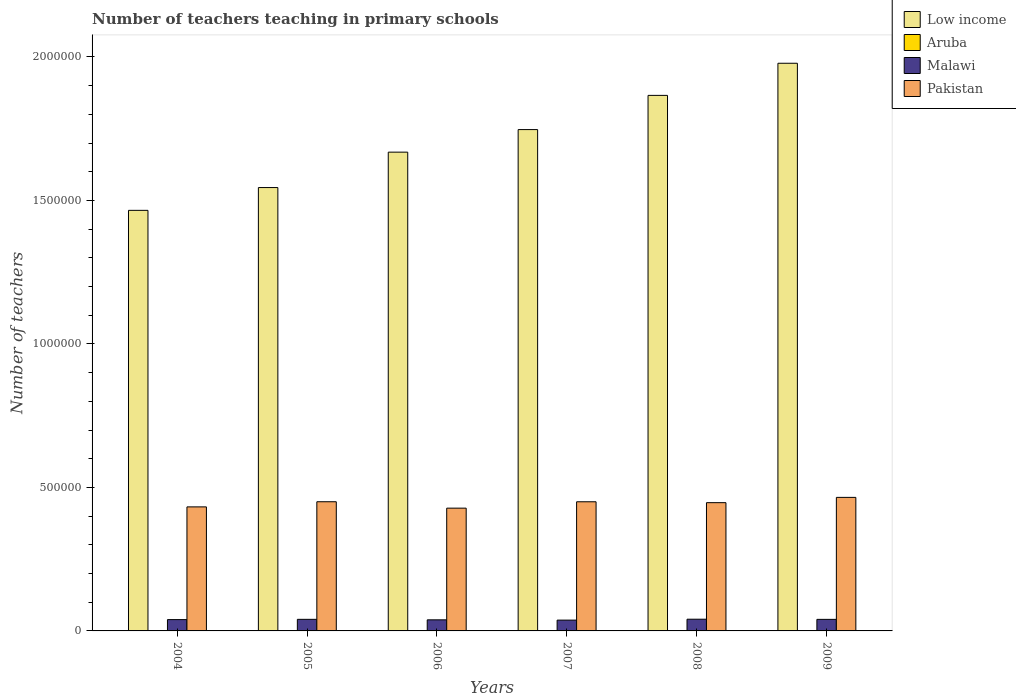How many groups of bars are there?
Give a very brief answer. 6. How many bars are there on the 6th tick from the right?
Your answer should be very brief. 4. What is the label of the 4th group of bars from the left?
Your answer should be very brief. 2007. What is the number of teachers teaching in primary schools in Malawi in 2006?
Provide a short and direct response. 3.86e+04. Across all years, what is the maximum number of teachers teaching in primary schools in Pakistan?
Your response must be concise. 4.65e+05. Across all years, what is the minimum number of teachers teaching in primary schools in Malawi?
Your answer should be very brief. 3.77e+04. In which year was the number of teachers teaching in primary schools in Malawi minimum?
Your answer should be compact. 2007. What is the total number of teachers teaching in primary schools in Pakistan in the graph?
Provide a succinct answer. 2.67e+06. What is the difference between the number of teachers teaching in primary schools in Pakistan in 2005 and that in 2007?
Give a very brief answer. 109. What is the difference between the number of teachers teaching in primary schools in Pakistan in 2006 and the number of teachers teaching in primary schools in Low income in 2004?
Offer a terse response. -1.04e+06. What is the average number of teachers teaching in primary schools in Low income per year?
Your answer should be compact. 1.71e+06. In the year 2007, what is the difference between the number of teachers teaching in primary schools in Aruba and number of teachers teaching in primary schools in Pakistan?
Offer a terse response. -4.49e+05. What is the ratio of the number of teachers teaching in primary schools in Pakistan in 2005 to that in 2006?
Your answer should be very brief. 1.05. What is the difference between the highest and the second highest number of teachers teaching in primary schools in Pakistan?
Your answer should be very brief. 1.52e+04. What is the difference between the highest and the lowest number of teachers teaching in primary schools in Aruba?
Your answer should be compact. 42. In how many years, is the number of teachers teaching in primary schools in Low income greater than the average number of teachers teaching in primary schools in Low income taken over all years?
Offer a terse response. 3. Is the sum of the number of teachers teaching in primary schools in Aruba in 2004 and 2008 greater than the maximum number of teachers teaching in primary schools in Pakistan across all years?
Make the answer very short. No. What does the 2nd bar from the left in 2009 represents?
Your response must be concise. Aruba. What does the 4th bar from the right in 2008 represents?
Keep it short and to the point. Low income. What is the difference between two consecutive major ticks on the Y-axis?
Your response must be concise. 5.00e+05. Are the values on the major ticks of Y-axis written in scientific E-notation?
Give a very brief answer. No. Does the graph contain any zero values?
Keep it short and to the point. No. What is the title of the graph?
Make the answer very short. Number of teachers teaching in primary schools. Does "Rwanda" appear as one of the legend labels in the graph?
Your answer should be very brief. No. What is the label or title of the X-axis?
Provide a short and direct response. Years. What is the label or title of the Y-axis?
Keep it short and to the point. Number of teachers. What is the Number of teachers of Low income in 2004?
Ensure brevity in your answer.  1.47e+06. What is the Number of teachers in Aruba in 2004?
Provide a succinct answer. 552. What is the Number of teachers of Malawi in 2004?
Provide a succinct answer. 3.94e+04. What is the Number of teachers in Pakistan in 2004?
Provide a succinct answer. 4.32e+05. What is the Number of teachers in Low income in 2005?
Your answer should be very brief. 1.55e+06. What is the Number of teachers of Aruba in 2005?
Make the answer very short. 567. What is the Number of teachers of Malawi in 2005?
Your response must be concise. 4.04e+04. What is the Number of teachers of Pakistan in 2005?
Offer a very short reply. 4.50e+05. What is the Number of teachers of Low income in 2006?
Your response must be concise. 1.67e+06. What is the Number of teachers of Aruba in 2006?
Make the answer very short. 572. What is the Number of teachers of Malawi in 2006?
Your response must be concise. 3.86e+04. What is the Number of teachers of Pakistan in 2006?
Provide a short and direct response. 4.28e+05. What is the Number of teachers of Low income in 2007?
Give a very brief answer. 1.75e+06. What is the Number of teachers in Aruba in 2007?
Your answer should be very brief. 594. What is the Number of teachers in Malawi in 2007?
Make the answer very short. 3.77e+04. What is the Number of teachers in Pakistan in 2007?
Keep it short and to the point. 4.50e+05. What is the Number of teachers in Low income in 2008?
Offer a very short reply. 1.87e+06. What is the Number of teachers in Aruba in 2008?
Keep it short and to the point. 579. What is the Number of teachers of Malawi in 2008?
Offer a terse response. 4.08e+04. What is the Number of teachers in Pakistan in 2008?
Your answer should be very brief. 4.47e+05. What is the Number of teachers in Low income in 2009?
Give a very brief answer. 1.98e+06. What is the Number of teachers in Aruba in 2009?
Your answer should be compact. 582. What is the Number of teachers in Malawi in 2009?
Offer a very short reply. 4.03e+04. What is the Number of teachers of Pakistan in 2009?
Offer a terse response. 4.65e+05. Across all years, what is the maximum Number of teachers in Low income?
Make the answer very short. 1.98e+06. Across all years, what is the maximum Number of teachers of Aruba?
Give a very brief answer. 594. Across all years, what is the maximum Number of teachers in Malawi?
Provide a succinct answer. 4.08e+04. Across all years, what is the maximum Number of teachers in Pakistan?
Provide a succinct answer. 4.65e+05. Across all years, what is the minimum Number of teachers in Low income?
Give a very brief answer. 1.47e+06. Across all years, what is the minimum Number of teachers of Aruba?
Your answer should be compact. 552. Across all years, what is the minimum Number of teachers of Malawi?
Make the answer very short. 3.77e+04. Across all years, what is the minimum Number of teachers of Pakistan?
Give a very brief answer. 4.28e+05. What is the total Number of teachers of Low income in the graph?
Your answer should be compact. 1.03e+07. What is the total Number of teachers of Aruba in the graph?
Make the answer very short. 3446. What is the total Number of teachers of Malawi in the graph?
Give a very brief answer. 2.37e+05. What is the total Number of teachers in Pakistan in the graph?
Offer a very short reply. 2.67e+06. What is the difference between the Number of teachers in Low income in 2004 and that in 2005?
Ensure brevity in your answer.  -7.94e+04. What is the difference between the Number of teachers in Malawi in 2004 and that in 2005?
Your response must be concise. -952. What is the difference between the Number of teachers of Pakistan in 2004 and that in 2005?
Give a very brief answer. -1.79e+04. What is the difference between the Number of teachers of Low income in 2004 and that in 2006?
Your answer should be very brief. -2.03e+05. What is the difference between the Number of teachers of Malawi in 2004 and that in 2006?
Give a very brief answer. 813. What is the difference between the Number of teachers of Pakistan in 2004 and that in 2006?
Ensure brevity in your answer.  4392. What is the difference between the Number of teachers in Low income in 2004 and that in 2007?
Your answer should be very brief. -2.81e+05. What is the difference between the Number of teachers of Aruba in 2004 and that in 2007?
Give a very brief answer. -42. What is the difference between the Number of teachers of Malawi in 2004 and that in 2007?
Make the answer very short. 1764. What is the difference between the Number of teachers of Pakistan in 2004 and that in 2007?
Offer a very short reply. -1.78e+04. What is the difference between the Number of teachers in Low income in 2004 and that in 2008?
Your answer should be compact. -4.01e+05. What is the difference between the Number of teachers in Malawi in 2004 and that in 2008?
Ensure brevity in your answer.  -1348. What is the difference between the Number of teachers in Pakistan in 2004 and that in 2008?
Ensure brevity in your answer.  -1.47e+04. What is the difference between the Number of teachers of Low income in 2004 and that in 2009?
Give a very brief answer. -5.13e+05. What is the difference between the Number of teachers in Malawi in 2004 and that in 2009?
Keep it short and to the point. -845. What is the difference between the Number of teachers in Pakistan in 2004 and that in 2009?
Make the answer very short. -3.31e+04. What is the difference between the Number of teachers in Low income in 2005 and that in 2006?
Make the answer very short. -1.23e+05. What is the difference between the Number of teachers in Aruba in 2005 and that in 2006?
Provide a short and direct response. -5. What is the difference between the Number of teachers in Malawi in 2005 and that in 2006?
Make the answer very short. 1765. What is the difference between the Number of teachers in Pakistan in 2005 and that in 2006?
Give a very brief answer. 2.23e+04. What is the difference between the Number of teachers of Low income in 2005 and that in 2007?
Give a very brief answer. -2.02e+05. What is the difference between the Number of teachers of Aruba in 2005 and that in 2007?
Make the answer very short. -27. What is the difference between the Number of teachers of Malawi in 2005 and that in 2007?
Offer a very short reply. 2716. What is the difference between the Number of teachers of Pakistan in 2005 and that in 2007?
Your answer should be compact. 109. What is the difference between the Number of teachers of Low income in 2005 and that in 2008?
Make the answer very short. -3.21e+05. What is the difference between the Number of teachers in Aruba in 2005 and that in 2008?
Provide a short and direct response. -12. What is the difference between the Number of teachers in Malawi in 2005 and that in 2008?
Provide a succinct answer. -396. What is the difference between the Number of teachers in Pakistan in 2005 and that in 2008?
Give a very brief answer. 3211. What is the difference between the Number of teachers in Low income in 2005 and that in 2009?
Make the answer very short. -4.33e+05. What is the difference between the Number of teachers in Malawi in 2005 and that in 2009?
Ensure brevity in your answer.  107. What is the difference between the Number of teachers in Pakistan in 2005 and that in 2009?
Ensure brevity in your answer.  -1.52e+04. What is the difference between the Number of teachers of Low income in 2006 and that in 2007?
Make the answer very short. -7.86e+04. What is the difference between the Number of teachers of Malawi in 2006 and that in 2007?
Your answer should be very brief. 951. What is the difference between the Number of teachers in Pakistan in 2006 and that in 2007?
Give a very brief answer. -2.22e+04. What is the difference between the Number of teachers in Low income in 2006 and that in 2008?
Provide a succinct answer. -1.98e+05. What is the difference between the Number of teachers in Malawi in 2006 and that in 2008?
Your response must be concise. -2161. What is the difference between the Number of teachers in Pakistan in 2006 and that in 2008?
Offer a terse response. -1.91e+04. What is the difference between the Number of teachers in Low income in 2006 and that in 2009?
Ensure brevity in your answer.  -3.10e+05. What is the difference between the Number of teachers in Aruba in 2006 and that in 2009?
Your answer should be very brief. -10. What is the difference between the Number of teachers of Malawi in 2006 and that in 2009?
Provide a short and direct response. -1658. What is the difference between the Number of teachers in Pakistan in 2006 and that in 2009?
Keep it short and to the point. -3.75e+04. What is the difference between the Number of teachers in Low income in 2007 and that in 2008?
Provide a short and direct response. -1.19e+05. What is the difference between the Number of teachers in Malawi in 2007 and that in 2008?
Your answer should be very brief. -3112. What is the difference between the Number of teachers in Pakistan in 2007 and that in 2008?
Your answer should be compact. 3102. What is the difference between the Number of teachers of Low income in 2007 and that in 2009?
Give a very brief answer. -2.31e+05. What is the difference between the Number of teachers of Aruba in 2007 and that in 2009?
Your response must be concise. 12. What is the difference between the Number of teachers of Malawi in 2007 and that in 2009?
Provide a succinct answer. -2609. What is the difference between the Number of teachers in Pakistan in 2007 and that in 2009?
Offer a terse response. -1.53e+04. What is the difference between the Number of teachers of Low income in 2008 and that in 2009?
Your response must be concise. -1.12e+05. What is the difference between the Number of teachers in Malawi in 2008 and that in 2009?
Your answer should be compact. 503. What is the difference between the Number of teachers in Pakistan in 2008 and that in 2009?
Your answer should be compact. -1.84e+04. What is the difference between the Number of teachers of Low income in 2004 and the Number of teachers of Aruba in 2005?
Your answer should be very brief. 1.46e+06. What is the difference between the Number of teachers in Low income in 2004 and the Number of teachers in Malawi in 2005?
Keep it short and to the point. 1.43e+06. What is the difference between the Number of teachers in Low income in 2004 and the Number of teachers in Pakistan in 2005?
Provide a short and direct response. 1.02e+06. What is the difference between the Number of teachers of Aruba in 2004 and the Number of teachers of Malawi in 2005?
Make the answer very short. -3.98e+04. What is the difference between the Number of teachers of Aruba in 2004 and the Number of teachers of Pakistan in 2005?
Make the answer very short. -4.50e+05. What is the difference between the Number of teachers in Malawi in 2004 and the Number of teachers in Pakistan in 2005?
Your answer should be very brief. -4.11e+05. What is the difference between the Number of teachers of Low income in 2004 and the Number of teachers of Aruba in 2006?
Provide a succinct answer. 1.46e+06. What is the difference between the Number of teachers of Low income in 2004 and the Number of teachers of Malawi in 2006?
Make the answer very short. 1.43e+06. What is the difference between the Number of teachers in Low income in 2004 and the Number of teachers in Pakistan in 2006?
Make the answer very short. 1.04e+06. What is the difference between the Number of teachers in Aruba in 2004 and the Number of teachers in Malawi in 2006?
Your answer should be compact. -3.81e+04. What is the difference between the Number of teachers in Aruba in 2004 and the Number of teachers in Pakistan in 2006?
Provide a succinct answer. -4.27e+05. What is the difference between the Number of teachers of Malawi in 2004 and the Number of teachers of Pakistan in 2006?
Your response must be concise. -3.88e+05. What is the difference between the Number of teachers in Low income in 2004 and the Number of teachers in Aruba in 2007?
Give a very brief answer. 1.46e+06. What is the difference between the Number of teachers of Low income in 2004 and the Number of teachers of Malawi in 2007?
Give a very brief answer. 1.43e+06. What is the difference between the Number of teachers in Low income in 2004 and the Number of teachers in Pakistan in 2007?
Ensure brevity in your answer.  1.02e+06. What is the difference between the Number of teachers of Aruba in 2004 and the Number of teachers of Malawi in 2007?
Make the answer very short. -3.71e+04. What is the difference between the Number of teachers of Aruba in 2004 and the Number of teachers of Pakistan in 2007?
Your answer should be very brief. -4.49e+05. What is the difference between the Number of teachers of Malawi in 2004 and the Number of teachers of Pakistan in 2007?
Provide a succinct answer. -4.11e+05. What is the difference between the Number of teachers of Low income in 2004 and the Number of teachers of Aruba in 2008?
Give a very brief answer. 1.46e+06. What is the difference between the Number of teachers of Low income in 2004 and the Number of teachers of Malawi in 2008?
Provide a succinct answer. 1.42e+06. What is the difference between the Number of teachers of Low income in 2004 and the Number of teachers of Pakistan in 2008?
Ensure brevity in your answer.  1.02e+06. What is the difference between the Number of teachers in Aruba in 2004 and the Number of teachers in Malawi in 2008?
Provide a succinct answer. -4.02e+04. What is the difference between the Number of teachers in Aruba in 2004 and the Number of teachers in Pakistan in 2008?
Make the answer very short. -4.46e+05. What is the difference between the Number of teachers of Malawi in 2004 and the Number of teachers of Pakistan in 2008?
Keep it short and to the point. -4.07e+05. What is the difference between the Number of teachers of Low income in 2004 and the Number of teachers of Aruba in 2009?
Offer a very short reply. 1.46e+06. What is the difference between the Number of teachers of Low income in 2004 and the Number of teachers of Malawi in 2009?
Keep it short and to the point. 1.43e+06. What is the difference between the Number of teachers in Low income in 2004 and the Number of teachers in Pakistan in 2009?
Provide a short and direct response. 1.00e+06. What is the difference between the Number of teachers in Aruba in 2004 and the Number of teachers in Malawi in 2009?
Your response must be concise. -3.97e+04. What is the difference between the Number of teachers of Aruba in 2004 and the Number of teachers of Pakistan in 2009?
Provide a short and direct response. -4.65e+05. What is the difference between the Number of teachers of Malawi in 2004 and the Number of teachers of Pakistan in 2009?
Your answer should be very brief. -4.26e+05. What is the difference between the Number of teachers in Low income in 2005 and the Number of teachers in Aruba in 2006?
Provide a short and direct response. 1.54e+06. What is the difference between the Number of teachers in Low income in 2005 and the Number of teachers in Malawi in 2006?
Make the answer very short. 1.51e+06. What is the difference between the Number of teachers in Low income in 2005 and the Number of teachers in Pakistan in 2006?
Ensure brevity in your answer.  1.12e+06. What is the difference between the Number of teachers in Aruba in 2005 and the Number of teachers in Malawi in 2006?
Give a very brief answer. -3.81e+04. What is the difference between the Number of teachers of Aruba in 2005 and the Number of teachers of Pakistan in 2006?
Keep it short and to the point. -4.27e+05. What is the difference between the Number of teachers in Malawi in 2005 and the Number of teachers in Pakistan in 2006?
Your response must be concise. -3.87e+05. What is the difference between the Number of teachers in Low income in 2005 and the Number of teachers in Aruba in 2007?
Give a very brief answer. 1.54e+06. What is the difference between the Number of teachers of Low income in 2005 and the Number of teachers of Malawi in 2007?
Make the answer very short. 1.51e+06. What is the difference between the Number of teachers in Low income in 2005 and the Number of teachers in Pakistan in 2007?
Your response must be concise. 1.09e+06. What is the difference between the Number of teachers of Aruba in 2005 and the Number of teachers of Malawi in 2007?
Your answer should be compact. -3.71e+04. What is the difference between the Number of teachers of Aruba in 2005 and the Number of teachers of Pakistan in 2007?
Keep it short and to the point. -4.49e+05. What is the difference between the Number of teachers of Malawi in 2005 and the Number of teachers of Pakistan in 2007?
Give a very brief answer. -4.10e+05. What is the difference between the Number of teachers of Low income in 2005 and the Number of teachers of Aruba in 2008?
Your answer should be compact. 1.54e+06. What is the difference between the Number of teachers of Low income in 2005 and the Number of teachers of Malawi in 2008?
Keep it short and to the point. 1.50e+06. What is the difference between the Number of teachers of Low income in 2005 and the Number of teachers of Pakistan in 2008?
Ensure brevity in your answer.  1.10e+06. What is the difference between the Number of teachers in Aruba in 2005 and the Number of teachers in Malawi in 2008?
Ensure brevity in your answer.  -4.02e+04. What is the difference between the Number of teachers in Aruba in 2005 and the Number of teachers in Pakistan in 2008?
Keep it short and to the point. -4.46e+05. What is the difference between the Number of teachers of Malawi in 2005 and the Number of teachers of Pakistan in 2008?
Your answer should be very brief. -4.07e+05. What is the difference between the Number of teachers of Low income in 2005 and the Number of teachers of Aruba in 2009?
Your answer should be very brief. 1.54e+06. What is the difference between the Number of teachers of Low income in 2005 and the Number of teachers of Malawi in 2009?
Give a very brief answer. 1.50e+06. What is the difference between the Number of teachers in Low income in 2005 and the Number of teachers in Pakistan in 2009?
Make the answer very short. 1.08e+06. What is the difference between the Number of teachers in Aruba in 2005 and the Number of teachers in Malawi in 2009?
Offer a very short reply. -3.97e+04. What is the difference between the Number of teachers in Aruba in 2005 and the Number of teachers in Pakistan in 2009?
Ensure brevity in your answer.  -4.65e+05. What is the difference between the Number of teachers of Malawi in 2005 and the Number of teachers of Pakistan in 2009?
Your answer should be very brief. -4.25e+05. What is the difference between the Number of teachers of Low income in 2006 and the Number of teachers of Aruba in 2007?
Provide a succinct answer. 1.67e+06. What is the difference between the Number of teachers of Low income in 2006 and the Number of teachers of Malawi in 2007?
Offer a very short reply. 1.63e+06. What is the difference between the Number of teachers of Low income in 2006 and the Number of teachers of Pakistan in 2007?
Make the answer very short. 1.22e+06. What is the difference between the Number of teachers in Aruba in 2006 and the Number of teachers in Malawi in 2007?
Offer a very short reply. -3.71e+04. What is the difference between the Number of teachers in Aruba in 2006 and the Number of teachers in Pakistan in 2007?
Provide a succinct answer. -4.49e+05. What is the difference between the Number of teachers in Malawi in 2006 and the Number of teachers in Pakistan in 2007?
Provide a short and direct response. -4.11e+05. What is the difference between the Number of teachers in Low income in 2006 and the Number of teachers in Aruba in 2008?
Keep it short and to the point. 1.67e+06. What is the difference between the Number of teachers in Low income in 2006 and the Number of teachers in Malawi in 2008?
Provide a succinct answer. 1.63e+06. What is the difference between the Number of teachers in Low income in 2006 and the Number of teachers in Pakistan in 2008?
Your answer should be compact. 1.22e+06. What is the difference between the Number of teachers of Aruba in 2006 and the Number of teachers of Malawi in 2008?
Your answer should be very brief. -4.02e+04. What is the difference between the Number of teachers of Aruba in 2006 and the Number of teachers of Pakistan in 2008?
Offer a very short reply. -4.46e+05. What is the difference between the Number of teachers in Malawi in 2006 and the Number of teachers in Pakistan in 2008?
Offer a very short reply. -4.08e+05. What is the difference between the Number of teachers in Low income in 2006 and the Number of teachers in Aruba in 2009?
Provide a short and direct response. 1.67e+06. What is the difference between the Number of teachers in Low income in 2006 and the Number of teachers in Malawi in 2009?
Keep it short and to the point. 1.63e+06. What is the difference between the Number of teachers in Low income in 2006 and the Number of teachers in Pakistan in 2009?
Provide a short and direct response. 1.20e+06. What is the difference between the Number of teachers in Aruba in 2006 and the Number of teachers in Malawi in 2009?
Keep it short and to the point. -3.97e+04. What is the difference between the Number of teachers of Aruba in 2006 and the Number of teachers of Pakistan in 2009?
Your answer should be very brief. -4.65e+05. What is the difference between the Number of teachers of Malawi in 2006 and the Number of teachers of Pakistan in 2009?
Keep it short and to the point. -4.27e+05. What is the difference between the Number of teachers of Low income in 2007 and the Number of teachers of Aruba in 2008?
Keep it short and to the point. 1.75e+06. What is the difference between the Number of teachers in Low income in 2007 and the Number of teachers in Malawi in 2008?
Make the answer very short. 1.71e+06. What is the difference between the Number of teachers of Low income in 2007 and the Number of teachers of Pakistan in 2008?
Give a very brief answer. 1.30e+06. What is the difference between the Number of teachers in Aruba in 2007 and the Number of teachers in Malawi in 2008?
Offer a very short reply. -4.02e+04. What is the difference between the Number of teachers of Aruba in 2007 and the Number of teachers of Pakistan in 2008?
Your response must be concise. -4.46e+05. What is the difference between the Number of teachers of Malawi in 2007 and the Number of teachers of Pakistan in 2008?
Your response must be concise. -4.09e+05. What is the difference between the Number of teachers in Low income in 2007 and the Number of teachers in Aruba in 2009?
Give a very brief answer. 1.75e+06. What is the difference between the Number of teachers of Low income in 2007 and the Number of teachers of Malawi in 2009?
Provide a succinct answer. 1.71e+06. What is the difference between the Number of teachers in Low income in 2007 and the Number of teachers in Pakistan in 2009?
Offer a very short reply. 1.28e+06. What is the difference between the Number of teachers of Aruba in 2007 and the Number of teachers of Malawi in 2009?
Offer a terse response. -3.97e+04. What is the difference between the Number of teachers of Aruba in 2007 and the Number of teachers of Pakistan in 2009?
Offer a terse response. -4.65e+05. What is the difference between the Number of teachers of Malawi in 2007 and the Number of teachers of Pakistan in 2009?
Provide a short and direct response. -4.28e+05. What is the difference between the Number of teachers of Low income in 2008 and the Number of teachers of Aruba in 2009?
Offer a very short reply. 1.87e+06. What is the difference between the Number of teachers in Low income in 2008 and the Number of teachers in Malawi in 2009?
Keep it short and to the point. 1.83e+06. What is the difference between the Number of teachers in Low income in 2008 and the Number of teachers in Pakistan in 2009?
Ensure brevity in your answer.  1.40e+06. What is the difference between the Number of teachers of Aruba in 2008 and the Number of teachers of Malawi in 2009?
Your answer should be compact. -3.97e+04. What is the difference between the Number of teachers of Aruba in 2008 and the Number of teachers of Pakistan in 2009?
Your answer should be compact. -4.65e+05. What is the difference between the Number of teachers of Malawi in 2008 and the Number of teachers of Pakistan in 2009?
Offer a very short reply. -4.25e+05. What is the average Number of teachers of Low income per year?
Offer a very short reply. 1.71e+06. What is the average Number of teachers in Aruba per year?
Provide a short and direct response. 574.33. What is the average Number of teachers of Malawi per year?
Your answer should be compact. 3.95e+04. What is the average Number of teachers of Pakistan per year?
Provide a short and direct response. 4.45e+05. In the year 2004, what is the difference between the Number of teachers in Low income and Number of teachers in Aruba?
Provide a short and direct response. 1.47e+06. In the year 2004, what is the difference between the Number of teachers in Low income and Number of teachers in Malawi?
Offer a terse response. 1.43e+06. In the year 2004, what is the difference between the Number of teachers of Low income and Number of teachers of Pakistan?
Your answer should be compact. 1.03e+06. In the year 2004, what is the difference between the Number of teachers of Aruba and Number of teachers of Malawi?
Make the answer very short. -3.89e+04. In the year 2004, what is the difference between the Number of teachers in Aruba and Number of teachers in Pakistan?
Your response must be concise. -4.32e+05. In the year 2004, what is the difference between the Number of teachers of Malawi and Number of teachers of Pakistan?
Your answer should be compact. -3.93e+05. In the year 2005, what is the difference between the Number of teachers of Low income and Number of teachers of Aruba?
Ensure brevity in your answer.  1.54e+06. In the year 2005, what is the difference between the Number of teachers of Low income and Number of teachers of Malawi?
Your answer should be very brief. 1.50e+06. In the year 2005, what is the difference between the Number of teachers of Low income and Number of teachers of Pakistan?
Your answer should be very brief. 1.09e+06. In the year 2005, what is the difference between the Number of teachers of Aruba and Number of teachers of Malawi?
Keep it short and to the point. -3.98e+04. In the year 2005, what is the difference between the Number of teachers in Aruba and Number of teachers in Pakistan?
Keep it short and to the point. -4.50e+05. In the year 2005, what is the difference between the Number of teachers in Malawi and Number of teachers in Pakistan?
Provide a short and direct response. -4.10e+05. In the year 2006, what is the difference between the Number of teachers in Low income and Number of teachers in Aruba?
Offer a terse response. 1.67e+06. In the year 2006, what is the difference between the Number of teachers in Low income and Number of teachers in Malawi?
Make the answer very short. 1.63e+06. In the year 2006, what is the difference between the Number of teachers in Low income and Number of teachers in Pakistan?
Your response must be concise. 1.24e+06. In the year 2006, what is the difference between the Number of teachers of Aruba and Number of teachers of Malawi?
Give a very brief answer. -3.81e+04. In the year 2006, what is the difference between the Number of teachers of Aruba and Number of teachers of Pakistan?
Your answer should be very brief. -4.27e+05. In the year 2006, what is the difference between the Number of teachers of Malawi and Number of teachers of Pakistan?
Make the answer very short. -3.89e+05. In the year 2007, what is the difference between the Number of teachers of Low income and Number of teachers of Aruba?
Keep it short and to the point. 1.75e+06. In the year 2007, what is the difference between the Number of teachers of Low income and Number of teachers of Malawi?
Ensure brevity in your answer.  1.71e+06. In the year 2007, what is the difference between the Number of teachers in Low income and Number of teachers in Pakistan?
Offer a very short reply. 1.30e+06. In the year 2007, what is the difference between the Number of teachers of Aruba and Number of teachers of Malawi?
Offer a very short reply. -3.71e+04. In the year 2007, what is the difference between the Number of teachers of Aruba and Number of teachers of Pakistan?
Your answer should be compact. -4.49e+05. In the year 2007, what is the difference between the Number of teachers of Malawi and Number of teachers of Pakistan?
Offer a very short reply. -4.12e+05. In the year 2008, what is the difference between the Number of teachers of Low income and Number of teachers of Aruba?
Offer a very short reply. 1.87e+06. In the year 2008, what is the difference between the Number of teachers of Low income and Number of teachers of Malawi?
Offer a terse response. 1.83e+06. In the year 2008, what is the difference between the Number of teachers in Low income and Number of teachers in Pakistan?
Ensure brevity in your answer.  1.42e+06. In the year 2008, what is the difference between the Number of teachers of Aruba and Number of teachers of Malawi?
Provide a short and direct response. -4.02e+04. In the year 2008, what is the difference between the Number of teachers in Aruba and Number of teachers in Pakistan?
Offer a terse response. -4.46e+05. In the year 2008, what is the difference between the Number of teachers of Malawi and Number of teachers of Pakistan?
Your response must be concise. -4.06e+05. In the year 2009, what is the difference between the Number of teachers of Low income and Number of teachers of Aruba?
Make the answer very short. 1.98e+06. In the year 2009, what is the difference between the Number of teachers of Low income and Number of teachers of Malawi?
Make the answer very short. 1.94e+06. In the year 2009, what is the difference between the Number of teachers in Low income and Number of teachers in Pakistan?
Give a very brief answer. 1.51e+06. In the year 2009, what is the difference between the Number of teachers in Aruba and Number of teachers in Malawi?
Give a very brief answer. -3.97e+04. In the year 2009, what is the difference between the Number of teachers in Aruba and Number of teachers in Pakistan?
Provide a short and direct response. -4.65e+05. In the year 2009, what is the difference between the Number of teachers in Malawi and Number of teachers in Pakistan?
Provide a short and direct response. -4.25e+05. What is the ratio of the Number of teachers in Low income in 2004 to that in 2005?
Provide a succinct answer. 0.95. What is the ratio of the Number of teachers in Aruba in 2004 to that in 2005?
Keep it short and to the point. 0.97. What is the ratio of the Number of teachers in Malawi in 2004 to that in 2005?
Offer a terse response. 0.98. What is the ratio of the Number of teachers in Pakistan in 2004 to that in 2005?
Provide a short and direct response. 0.96. What is the ratio of the Number of teachers in Low income in 2004 to that in 2006?
Provide a succinct answer. 0.88. What is the ratio of the Number of teachers in Aruba in 2004 to that in 2006?
Make the answer very short. 0.96. What is the ratio of the Number of teachers of Pakistan in 2004 to that in 2006?
Offer a very short reply. 1.01. What is the ratio of the Number of teachers of Low income in 2004 to that in 2007?
Your answer should be very brief. 0.84. What is the ratio of the Number of teachers in Aruba in 2004 to that in 2007?
Your answer should be compact. 0.93. What is the ratio of the Number of teachers of Malawi in 2004 to that in 2007?
Give a very brief answer. 1.05. What is the ratio of the Number of teachers in Pakistan in 2004 to that in 2007?
Ensure brevity in your answer.  0.96. What is the ratio of the Number of teachers of Low income in 2004 to that in 2008?
Provide a short and direct response. 0.79. What is the ratio of the Number of teachers in Aruba in 2004 to that in 2008?
Your answer should be compact. 0.95. What is the ratio of the Number of teachers in Malawi in 2004 to that in 2008?
Offer a terse response. 0.97. What is the ratio of the Number of teachers of Pakistan in 2004 to that in 2008?
Provide a short and direct response. 0.97. What is the ratio of the Number of teachers in Low income in 2004 to that in 2009?
Make the answer very short. 0.74. What is the ratio of the Number of teachers of Aruba in 2004 to that in 2009?
Make the answer very short. 0.95. What is the ratio of the Number of teachers in Malawi in 2004 to that in 2009?
Offer a very short reply. 0.98. What is the ratio of the Number of teachers of Pakistan in 2004 to that in 2009?
Make the answer very short. 0.93. What is the ratio of the Number of teachers of Low income in 2005 to that in 2006?
Your answer should be compact. 0.93. What is the ratio of the Number of teachers of Aruba in 2005 to that in 2006?
Offer a very short reply. 0.99. What is the ratio of the Number of teachers in Malawi in 2005 to that in 2006?
Offer a terse response. 1.05. What is the ratio of the Number of teachers in Pakistan in 2005 to that in 2006?
Keep it short and to the point. 1.05. What is the ratio of the Number of teachers in Low income in 2005 to that in 2007?
Keep it short and to the point. 0.88. What is the ratio of the Number of teachers of Aruba in 2005 to that in 2007?
Your response must be concise. 0.95. What is the ratio of the Number of teachers of Malawi in 2005 to that in 2007?
Give a very brief answer. 1.07. What is the ratio of the Number of teachers in Low income in 2005 to that in 2008?
Make the answer very short. 0.83. What is the ratio of the Number of teachers of Aruba in 2005 to that in 2008?
Ensure brevity in your answer.  0.98. What is the ratio of the Number of teachers of Malawi in 2005 to that in 2008?
Your answer should be compact. 0.99. What is the ratio of the Number of teachers in Low income in 2005 to that in 2009?
Keep it short and to the point. 0.78. What is the ratio of the Number of teachers in Aruba in 2005 to that in 2009?
Your answer should be compact. 0.97. What is the ratio of the Number of teachers in Pakistan in 2005 to that in 2009?
Keep it short and to the point. 0.97. What is the ratio of the Number of teachers in Low income in 2006 to that in 2007?
Your answer should be compact. 0.95. What is the ratio of the Number of teachers of Malawi in 2006 to that in 2007?
Your answer should be compact. 1.03. What is the ratio of the Number of teachers in Pakistan in 2006 to that in 2007?
Your answer should be compact. 0.95. What is the ratio of the Number of teachers of Low income in 2006 to that in 2008?
Your answer should be very brief. 0.89. What is the ratio of the Number of teachers in Aruba in 2006 to that in 2008?
Give a very brief answer. 0.99. What is the ratio of the Number of teachers of Malawi in 2006 to that in 2008?
Ensure brevity in your answer.  0.95. What is the ratio of the Number of teachers in Pakistan in 2006 to that in 2008?
Offer a terse response. 0.96. What is the ratio of the Number of teachers in Low income in 2006 to that in 2009?
Offer a very short reply. 0.84. What is the ratio of the Number of teachers of Aruba in 2006 to that in 2009?
Make the answer very short. 0.98. What is the ratio of the Number of teachers in Malawi in 2006 to that in 2009?
Give a very brief answer. 0.96. What is the ratio of the Number of teachers in Pakistan in 2006 to that in 2009?
Your answer should be compact. 0.92. What is the ratio of the Number of teachers in Low income in 2007 to that in 2008?
Your answer should be very brief. 0.94. What is the ratio of the Number of teachers of Aruba in 2007 to that in 2008?
Offer a terse response. 1.03. What is the ratio of the Number of teachers of Malawi in 2007 to that in 2008?
Keep it short and to the point. 0.92. What is the ratio of the Number of teachers of Low income in 2007 to that in 2009?
Provide a succinct answer. 0.88. What is the ratio of the Number of teachers in Aruba in 2007 to that in 2009?
Offer a terse response. 1.02. What is the ratio of the Number of teachers of Malawi in 2007 to that in 2009?
Give a very brief answer. 0.94. What is the ratio of the Number of teachers in Pakistan in 2007 to that in 2009?
Keep it short and to the point. 0.97. What is the ratio of the Number of teachers in Low income in 2008 to that in 2009?
Make the answer very short. 0.94. What is the ratio of the Number of teachers of Aruba in 2008 to that in 2009?
Ensure brevity in your answer.  0.99. What is the ratio of the Number of teachers in Malawi in 2008 to that in 2009?
Ensure brevity in your answer.  1.01. What is the ratio of the Number of teachers in Pakistan in 2008 to that in 2009?
Your answer should be very brief. 0.96. What is the difference between the highest and the second highest Number of teachers in Low income?
Provide a short and direct response. 1.12e+05. What is the difference between the highest and the second highest Number of teachers in Malawi?
Your answer should be compact. 396. What is the difference between the highest and the second highest Number of teachers in Pakistan?
Offer a terse response. 1.52e+04. What is the difference between the highest and the lowest Number of teachers in Low income?
Offer a very short reply. 5.13e+05. What is the difference between the highest and the lowest Number of teachers of Malawi?
Ensure brevity in your answer.  3112. What is the difference between the highest and the lowest Number of teachers in Pakistan?
Provide a short and direct response. 3.75e+04. 